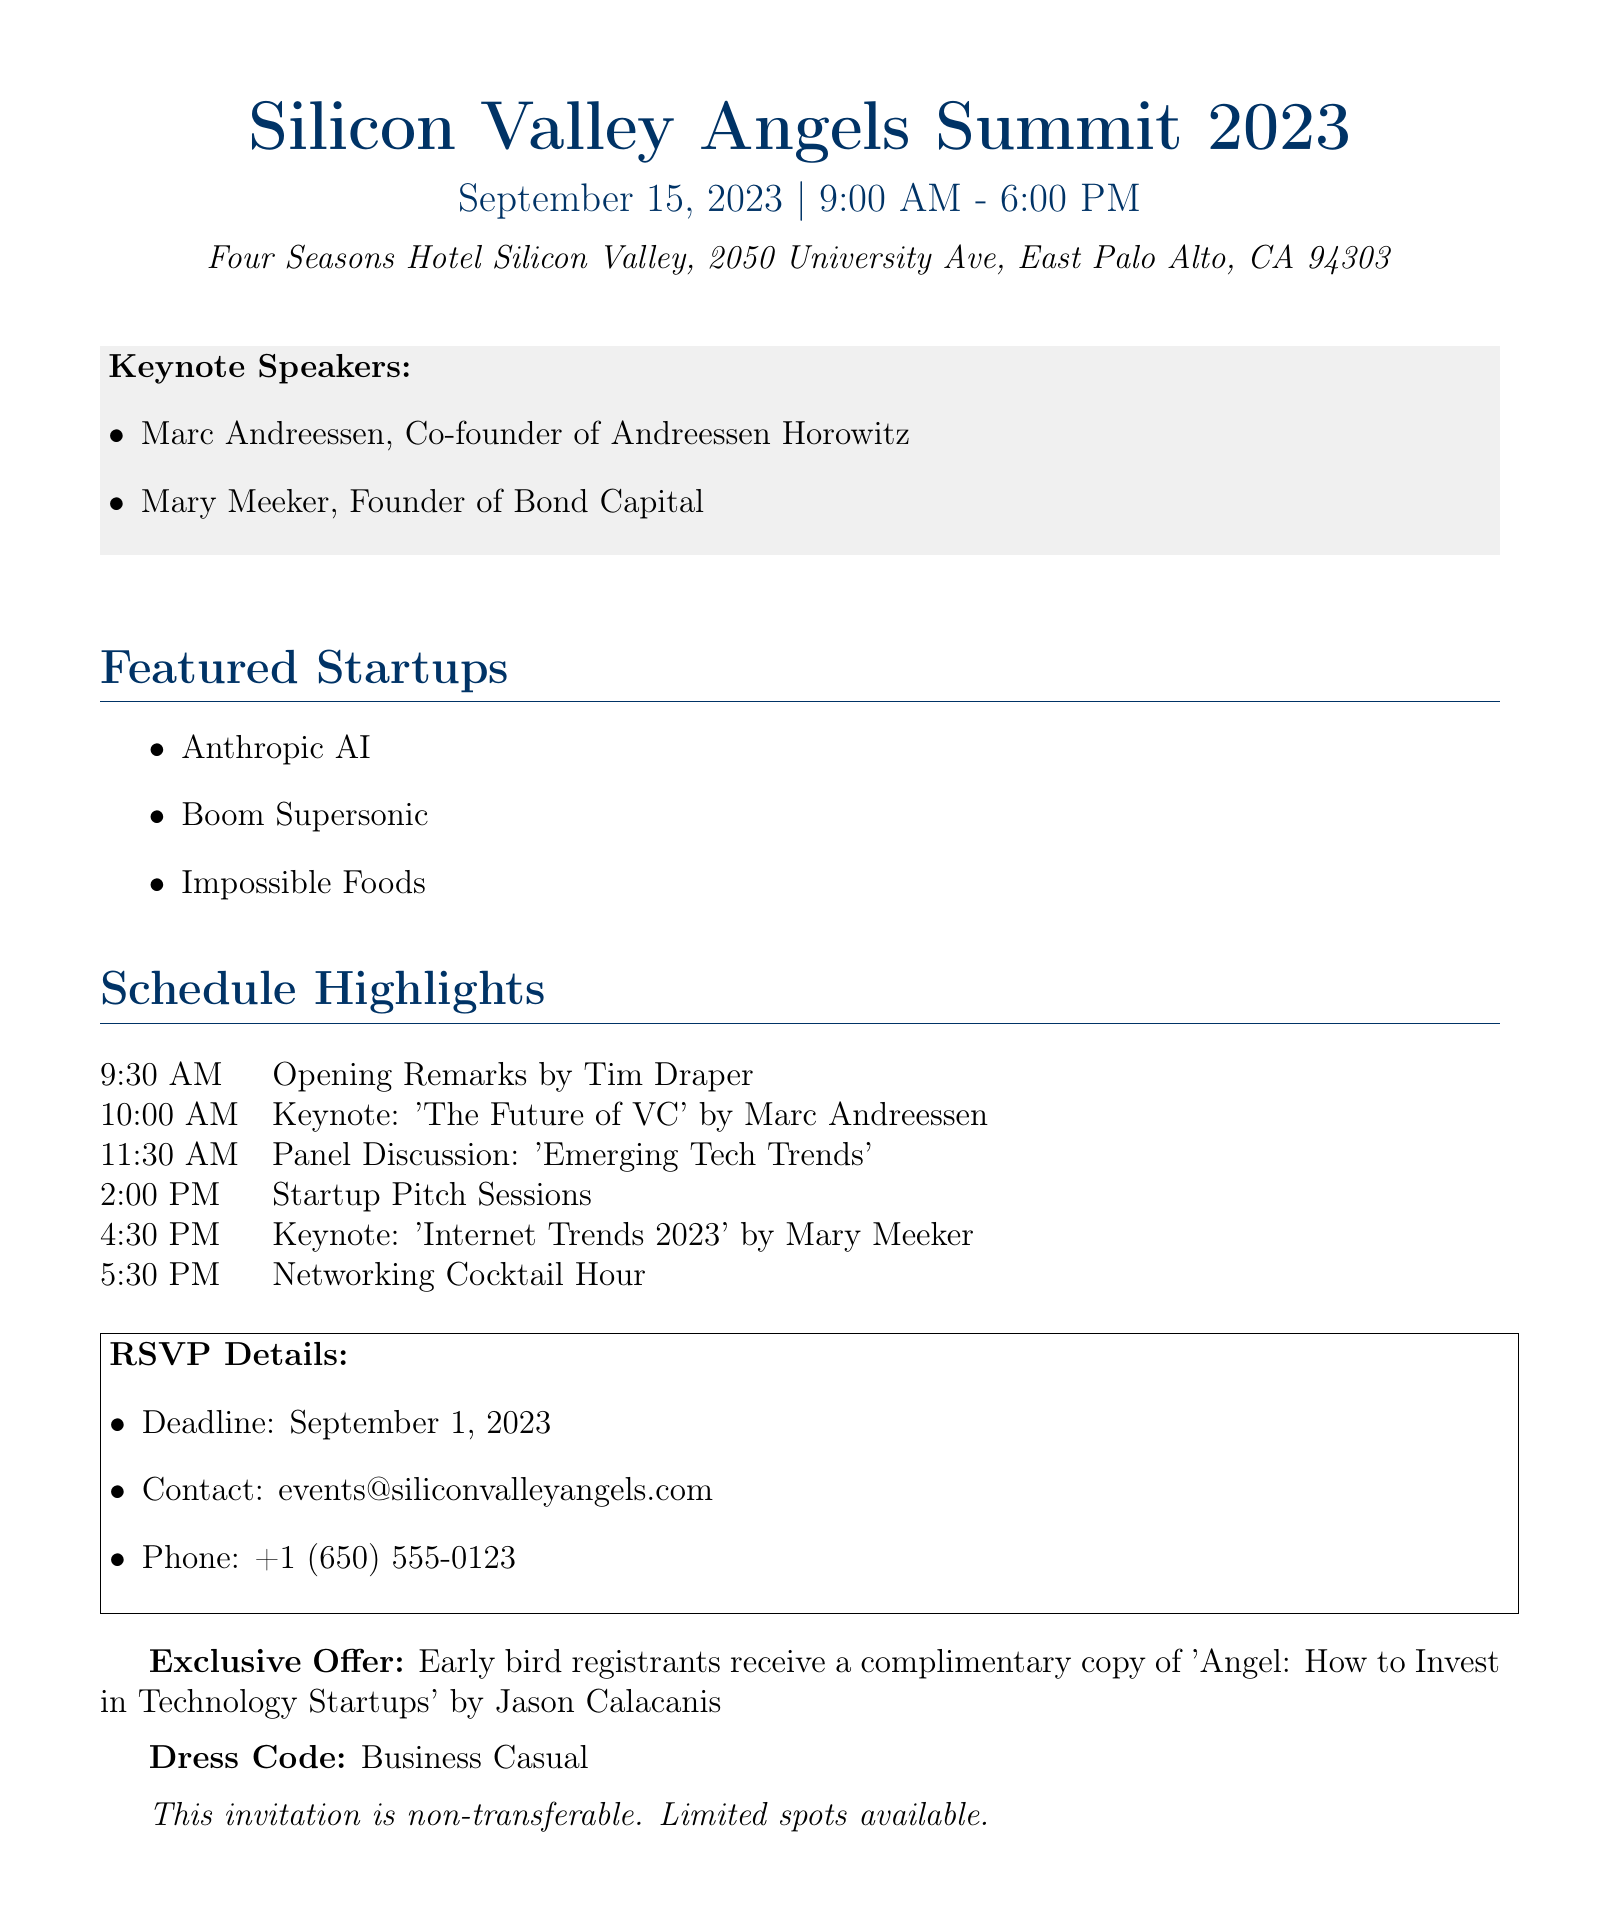What is the date of the event? The event is scheduled for September 15, 2023, as stated in the document's header.
Answer: September 15, 2023 What time does the event start? The event starts at 9:00 AM, which is mentioned prominently in the header section.
Answer: 9:00 AM Who is one of the keynote speakers? The document lists Marc Andreessen and Mary Meeker as keynote speakers under the Keynote Speakers section.
Answer: Marc Andreessen What is the location of the event? The document specifies that the event takes place at the Four Seasons Hotel Silicon Valley at a particular address.
Answer: Four Seasons Hotel Silicon Valley When is the RSVP deadline? The RSVP deadline is mentioned clearly in the RSVP Details section.
Answer: September 1, 2023 What is one of the featured startups? The document lists Anthropic AI, Boom Supersonic, and Impossible Foods as featured startups.
Answer: Anthropic AI What is the dress code for the event? The dress code is explicitly stated towards the end of the document.
Answer: Business Casual What exclusive offer is mentioned for early bird registrants? The document includes a special offer for early bird registrants that is highlighted in the text.
Answer: Complimentary copy of 'Angel: How to Invest in Technology Startups' How many keynote speakers are listed? By counting the names listed under the Keynote Speakers section, you can determine the number of speakers.
Answer: 2 What time is the networking cocktail hour scheduled? The document provides a specific time for the networking cocktail hour in the Schedule Highlights section.
Answer: 5:30 PM 